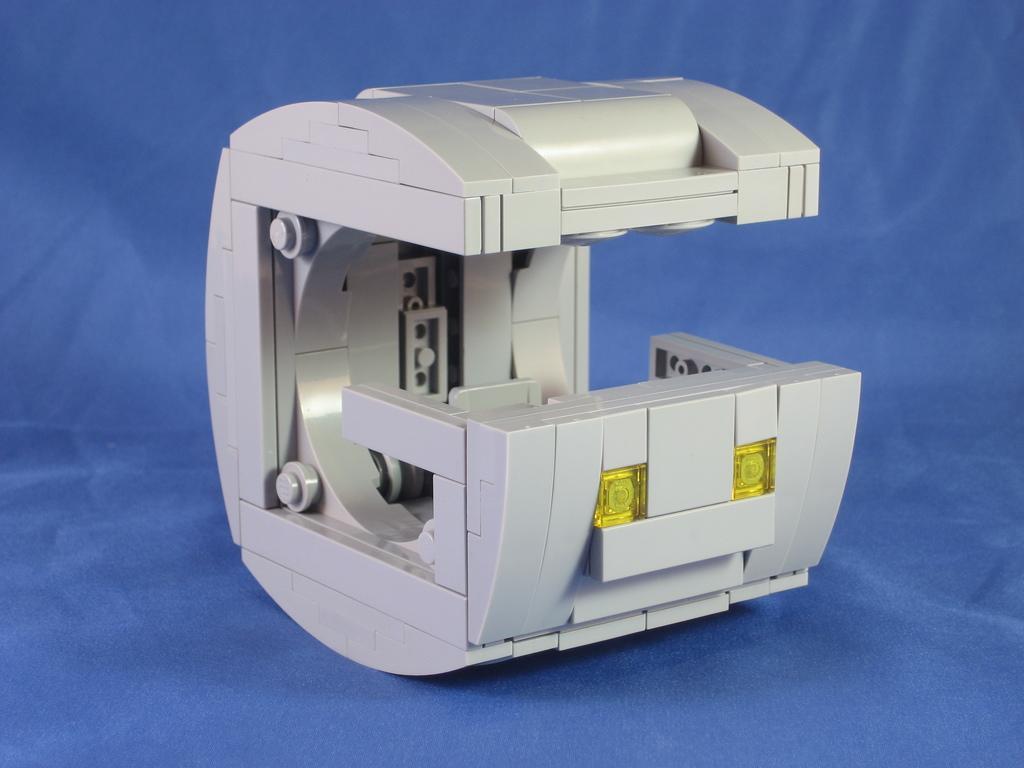Please provide a concise description of this image. In the picture we can see a instrument which is white in color on the blue colored surface. 